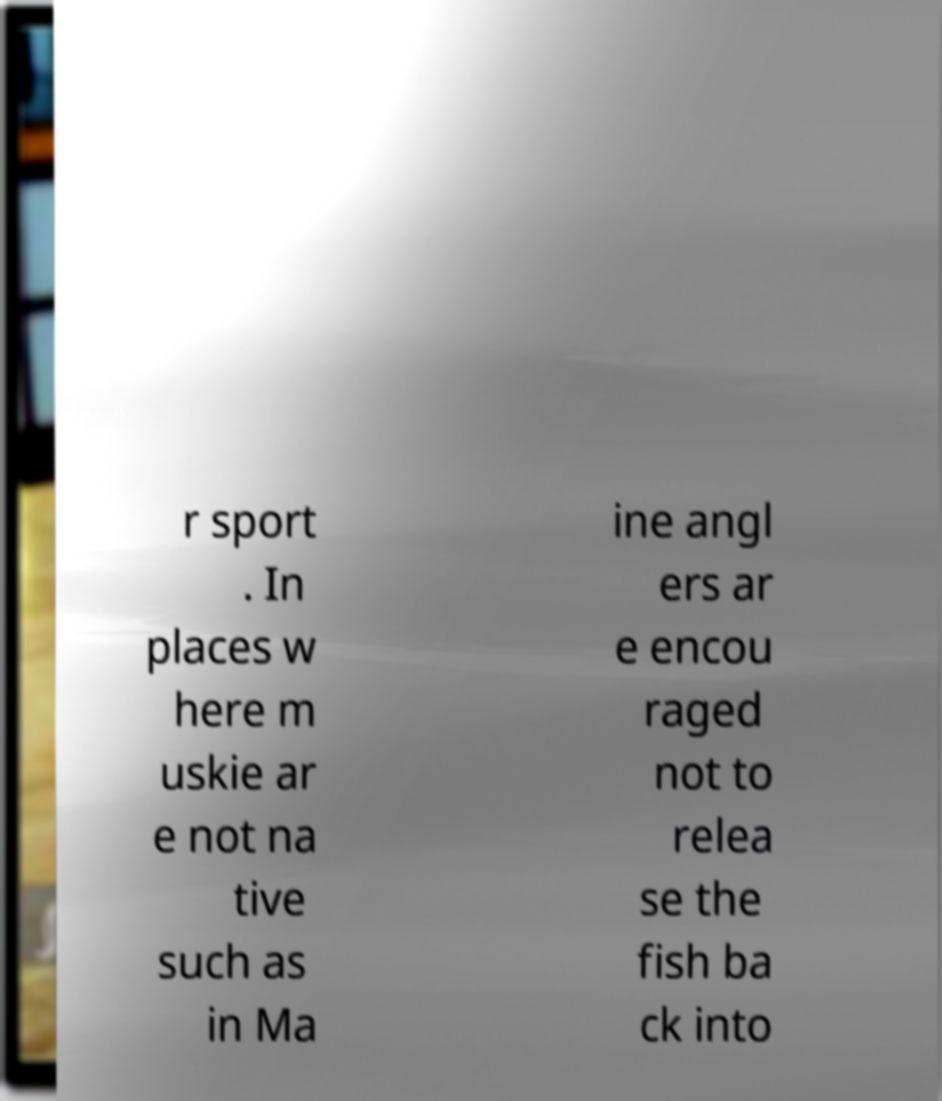I need the written content from this picture converted into text. Can you do that? r sport . In places w here m uskie ar e not na tive such as in Ma ine angl ers ar e encou raged not to relea se the fish ba ck into 